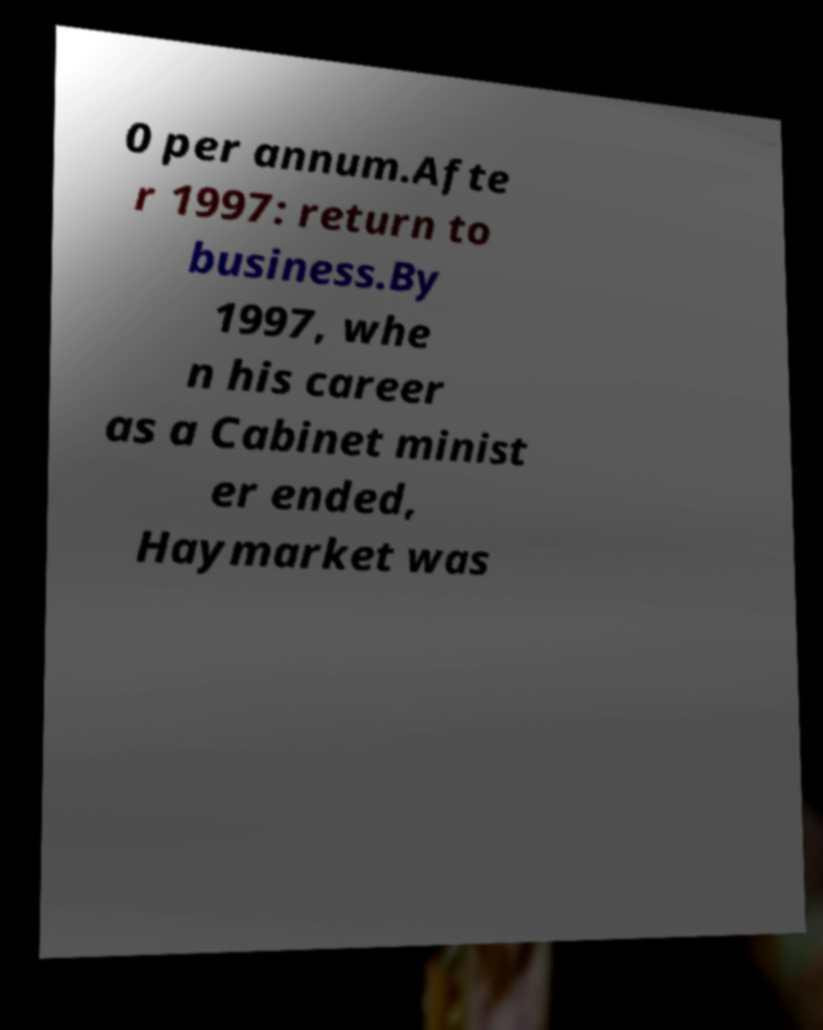Please identify and transcribe the text found in this image. 0 per annum.Afte r 1997: return to business.By 1997, whe n his career as a Cabinet minist er ended, Haymarket was 